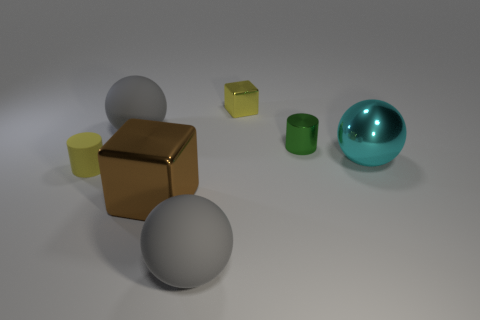Is the number of big shiny blocks greater than the number of large gray rubber objects?
Ensure brevity in your answer.  No. There is a cyan shiny object that is in front of the yellow cube that is on the left side of the cyan object; what size is it?
Make the answer very short. Large. There is a shiny object that is the same shape as the tiny matte thing; what color is it?
Give a very brief answer. Green. How big is the cyan metallic sphere?
Ensure brevity in your answer.  Large. How many spheres are either small brown shiny objects or tiny yellow metallic objects?
Offer a terse response. 0. What size is the other object that is the same shape as the brown metallic thing?
Provide a short and direct response. Small. What number of tiny yellow objects are there?
Make the answer very short. 2. Do the cyan metal thing and the big matte thing behind the green metal thing have the same shape?
Offer a terse response. Yes. There is a object that is right of the small green shiny cylinder; what is its size?
Give a very brief answer. Large. What is the material of the yellow cylinder?
Ensure brevity in your answer.  Rubber. 